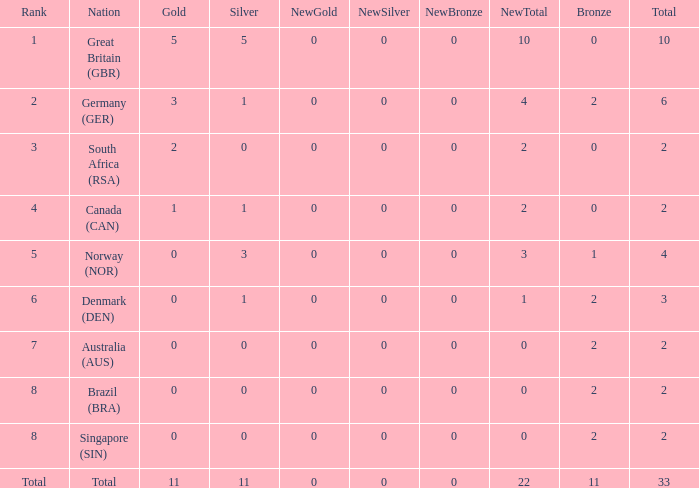What is the total when the nation is brazil (bra) and bronze is more than 2? None. 